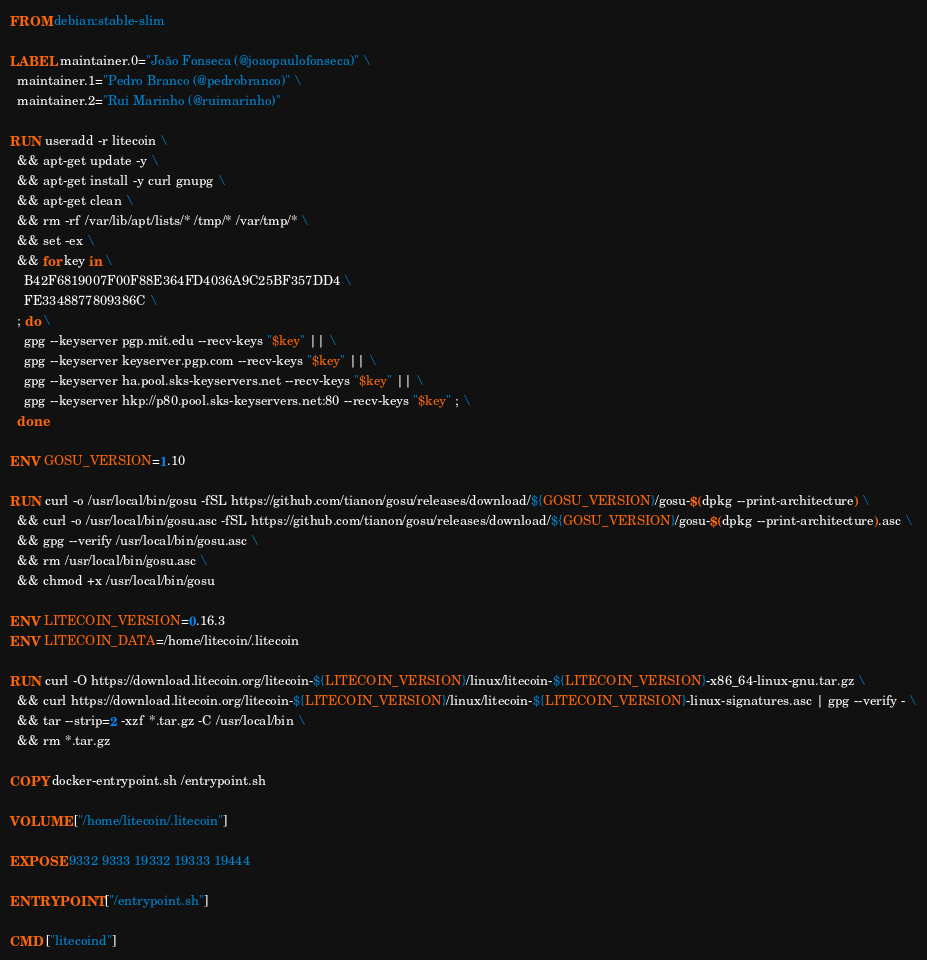Convert code to text. <code><loc_0><loc_0><loc_500><loc_500><_Dockerfile_>FROM debian:stable-slim

LABEL maintainer.0="João Fonseca (@joaopaulofonseca)" \
  maintainer.1="Pedro Branco (@pedrobranco)" \
  maintainer.2="Rui Marinho (@ruimarinho)"

RUN useradd -r litecoin \
  && apt-get update -y \
  && apt-get install -y curl gnupg \
  && apt-get clean \
  && rm -rf /var/lib/apt/lists/* /tmp/* /var/tmp/* \
  && set -ex \
  && for key in \
    B42F6819007F00F88E364FD4036A9C25BF357DD4 \
    FE3348877809386C \
  ; do \
    gpg --keyserver pgp.mit.edu --recv-keys "$key" || \
    gpg --keyserver keyserver.pgp.com --recv-keys "$key" || \
    gpg --keyserver ha.pool.sks-keyservers.net --recv-keys "$key" || \
    gpg --keyserver hkp://p80.pool.sks-keyservers.net:80 --recv-keys "$key" ; \
  done

ENV GOSU_VERSION=1.10

RUN curl -o /usr/local/bin/gosu -fSL https://github.com/tianon/gosu/releases/download/${GOSU_VERSION}/gosu-$(dpkg --print-architecture) \
  && curl -o /usr/local/bin/gosu.asc -fSL https://github.com/tianon/gosu/releases/download/${GOSU_VERSION}/gosu-$(dpkg --print-architecture).asc \
  && gpg --verify /usr/local/bin/gosu.asc \
  && rm /usr/local/bin/gosu.asc \
  && chmod +x /usr/local/bin/gosu

ENV LITECOIN_VERSION=0.16.3
ENV LITECOIN_DATA=/home/litecoin/.litecoin

RUN curl -O https://download.litecoin.org/litecoin-${LITECOIN_VERSION}/linux/litecoin-${LITECOIN_VERSION}-x86_64-linux-gnu.tar.gz \
  && curl https://download.litecoin.org/litecoin-${LITECOIN_VERSION}/linux/litecoin-${LITECOIN_VERSION}-linux-signatures.asc | gpg --verify - \
  && tar --strip=2 -xzf *.tar.gz -C /usr/local/bin \
  && rm *.tar.gz

COPY docker-entrypoint.sh /entrypoint.sh

VOLUME ["/home/litecoin/.litecoin"]

EXPOSE 9332 9333 19332 19333 19444

ENTRYPOINT ["/entrypoint.sh"]

CMD ["litecoind"]
</code> 